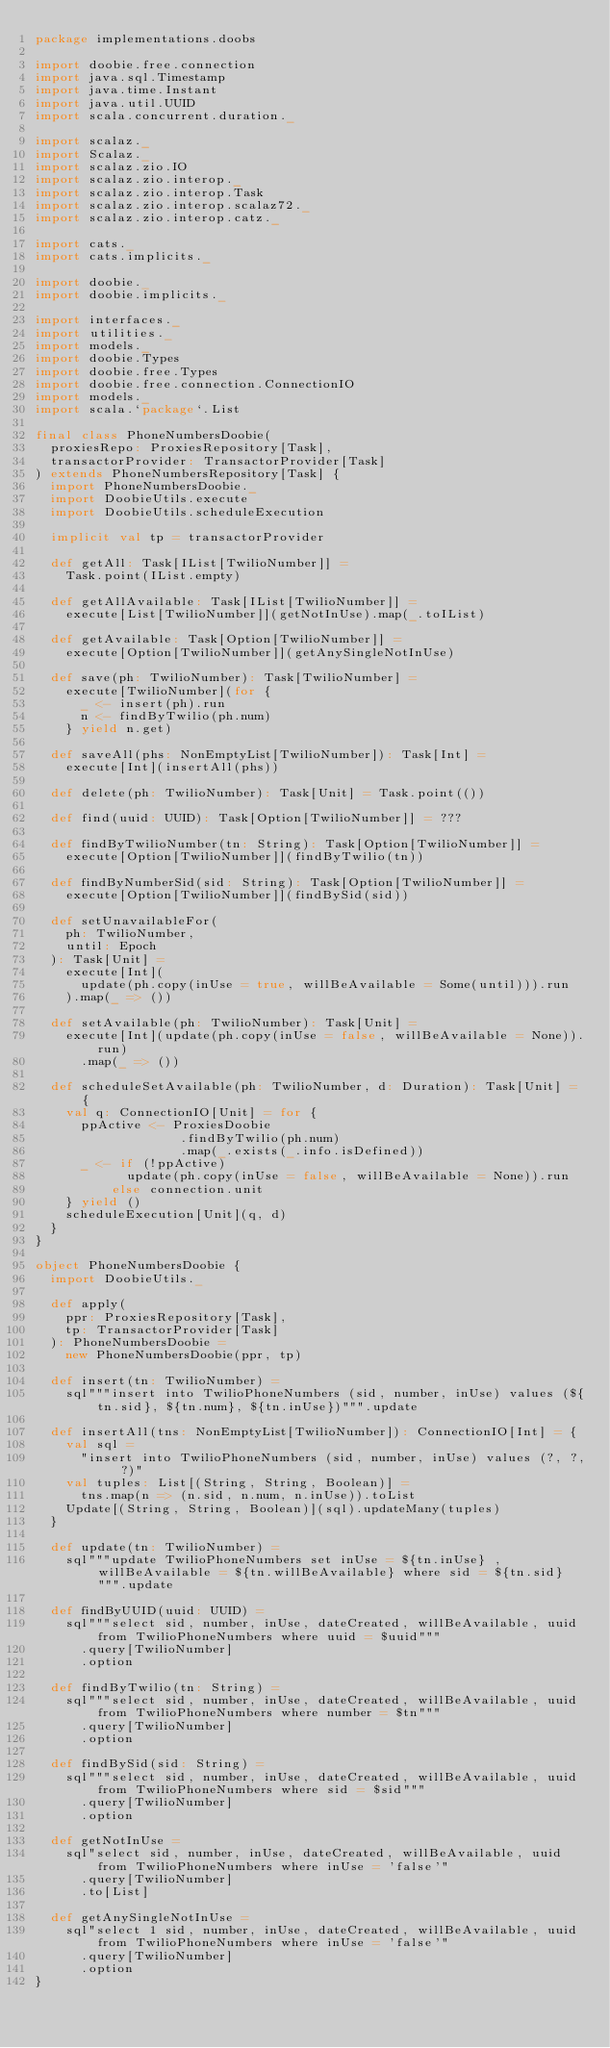<code> <loc_0><loc_0><loc_500><loc_500><_Scala_>package implementations.doobs

import doobie.free.connection
import java.sql.Timestamp
import java.time.Instant
import java.util.UUID
import scala.concurrent.duration._

import scalaz._
import Scalaz._
import scalaz.zio.IO
import scalaz.zio.interop._
import scalaz.zio.interop.Task
import scalaz.zio.interop.scalaz72._
import scalaz.zio.interop.catz._

import cats._
import cats.implicits._

import doobie._
import doobie.implicits._

import interfaces._
import utilities._
import models._
import doobie.Types
import doobie.free.Types
import doobie.free.connection.ConnectionIO
import models._
import scala.`package`.List

final class PhoneNumbersDoobie(
  proxiesRepo: ProxiesRepository[Task],
  transactorProvider: TransactorProvider[Task]
) extends PhoneNumbersRepository[Task] {
  import PhoneNumbersDoobie._
  import DoobieUtils.execute
  import DoobieUtils.scheduleExecution

  implicit val tp = transactorProvider

  def getAll: Task[IList[TwilioNumber]] =
    Task.point(IList.empty)

  def getAllAvailable: Task[IList[TwilioNumber]] =
    execute[List[TwilioNumber]](getNotInUse).map(_.toIList)

  def getAvailable: Task[Option[TwilioNumber]] =
    execute[Option[TwilioNumber]](getAnySingleNotInUse)

  def save(ph: TwilioNumber): Task[TwilioNumber] =
    execute[TwilioNumber](for {
      _ <- insert(ph).run
      n <- findByTwilio(ph.num)
    } yield n.get)

  def saveAll(phs: NonEmptyList[TwilioNumber]): Task[Int] =
    execute[Int](insertAll(phs))

  def delete(ph: TwilioNumber): Task[Unit] = Task.point(())

  def find(uuid: UUID): Task[Option[TwilioNumber]] = ???

  def findByTwilioNumber(tn: String): Task[Option[TwilioNumber]] =
    execute[Option[TwilioNumber]](findByTwilio(tn))

  def findByNumberSid(sid: String): Task[Option[TwilioNumber]] =
    execute[Option[TwilioNumber]](findBySid(sid))

  def setUnavailableFor(
    ph: TwilioNumber,
    until: Epoch
  ): Task[Unit] =
    execute[Int](
      update(ph.copy(inUse = true, willBeAvailable = Some(until))).run
    ).map(_ => ())

  def setAvailable(ph: TwilioNumber): Task[Unit] =
    execute[Int](update(ph.copy(inUse = false, willBeAvailable = None)).run)
      .map(_ => ())

  def scheduleSetAvailable(ph: TwilioNumber, d: Duration): Task[Unit] = {
    val q: ConnectionIO[Unit] = for {
      ppActive <- ProxiesDoobie
                   .findByTwilio(ph.num)
                   .map(_.exists(_.info.isDefined))
      _ <- if (!ppActive)
            update(ph.copy(inUse = false, willBeAvailable = None)).run
          else connection.unit
    } yield ()
    scheduleExecution[Unit](q, d)
  }
}

object PhoneNumbersDoobie {
  import DoobieUtils._

  def apply(
    ppr: ProxiesRepository[Task],
    tp: TransactorProvider[Task]
  ): PhoneNumbersDoobie =
    new PhoneNumbersDoobie(ppr, tp)

  def insert(tn: TwilioNumber) =
    sql"""insert into TwilioPhoneNumbers (sid, number, inUse) values (${tn.sid}, ${tn.num}, ${tn.inUse})""".update

  def insertAll(tns: NonEmptyList[TwilioNumber]): ConnectionIO[Int] = {
    val sql =
      "insert into TwilioPhoneNumbers (sid, number, inUse) values (?, ?, ?)"
    val tuples: List[(String, String, Boolean)] =
      tns.map(n => (n.sid, n.num, n.inUse)).toList
    Update[(String, String, Boolean)](sql).updateMany(tuples)
  }

  def update(tn: TwilioNumber) =
    sql"""update TwilioPhoneNumbers set inUse = ${tn.inUse} , willBeAvailable = ${tn.willBeAvailable} where sid = ${tn.sid}""".update

  def findByUUID(uuid: UUID) =
    sql"""select sid, number, inUse, dateCreated, willBeAvailable, uuid from TwilioPhoneNumbers where uuid = $uuid"""
      .query[TwilioNumber]
      .option

  def findByTwilio(tn: String) =
    sql"""select sid, number, inUse, dateCreated, willBeAvailable, uuid from TwilioPhoneNumbers where number = $tn"""
      .query[TwilioNumber]
      .option

  def findBySid(sid: String) =
    sql"""select sid, number, inUse, dateCreated, willBeAvailable, uuid from TwilioPhoneNumbers where sid = $sid"""
      .query[TwilioNumber]
      .option

  def getNotInUse =
    sql"select sid, number, inUse, dateCreated, willBeAvailable, uuid from TwilioPhoneNumbers where inUse = 'false'"
      .query[TwilioNumber]
      .to[List]

  def getAnySingleNotInUse =
    sql"select 1 sid, number, inUse, dateCreated, willBeAvailable, uuid from TwilioPhoneNumbers where inUse = 'false'"
      .query[TwilioNumber]
      .option
}
</code> 